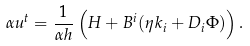Convert formula to latex. <formula><loc_0><loc_0><loc_500><loc_500>\alpha u ^ { t } = \frac { 1 } { \alpha h } \left ( H + B ^ { i } ( \eta k _ { i } + D _ { i } \Phi ) \right ) .</formula> 